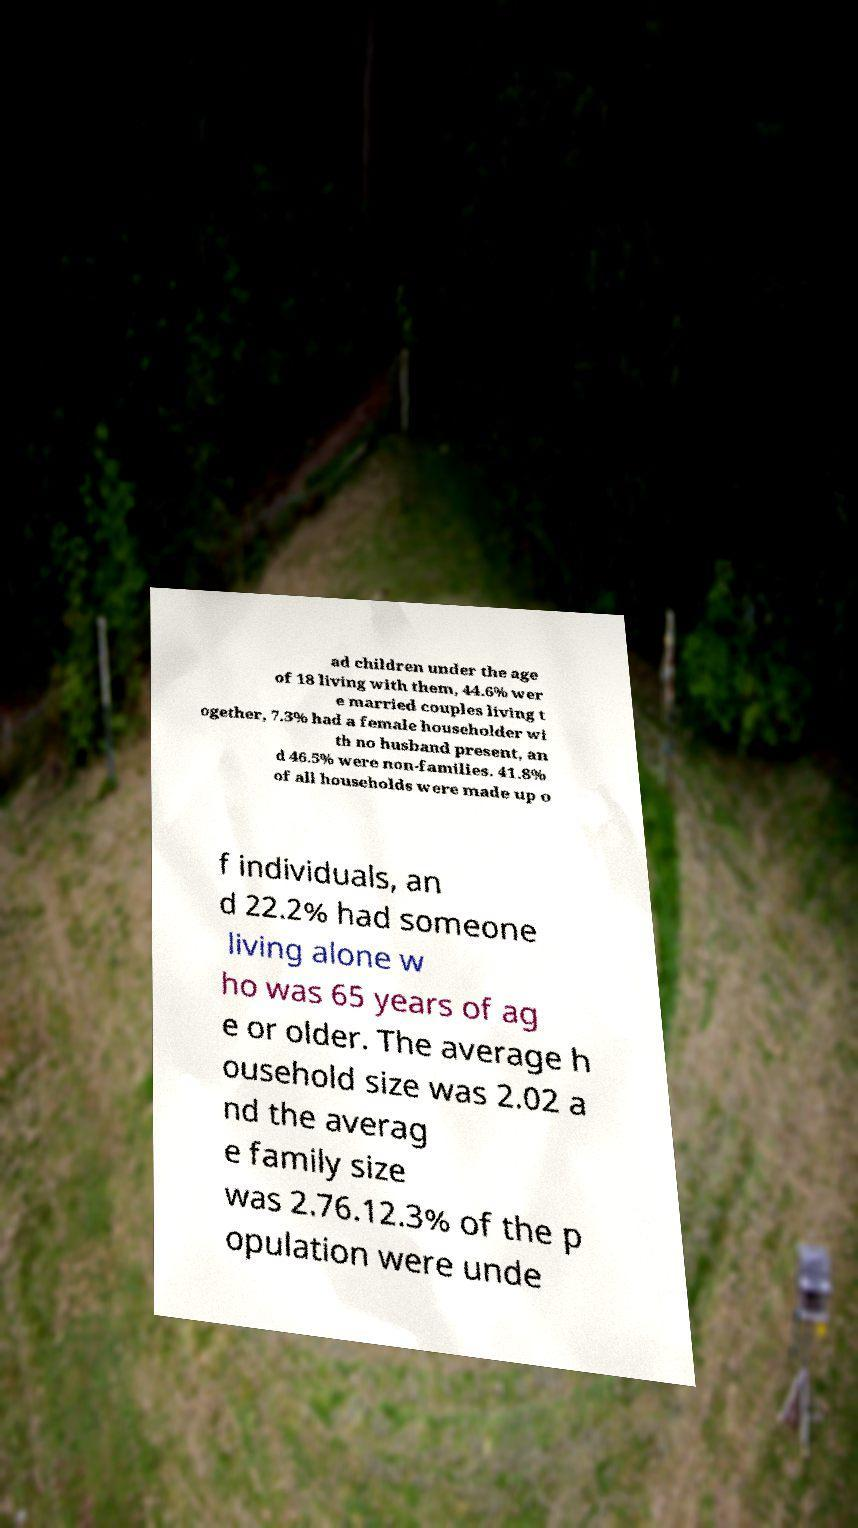For documentation purposes, I need the text within this image transcribed. Could you provide that? ad children under the age of 18 living with them, 44.6% wer e married couples living t ogether, 7.3% had a female householder wi th no husband present, an d 46.5% were non-families. 41.8% of all households were made up o f individuals, an d 22.2% had someone living alone w ho was 65 years of ag e or older. The average h ousehold size was 2.02 a nd the averag e family size was 2.76.12.3% of the p opulation were unde 